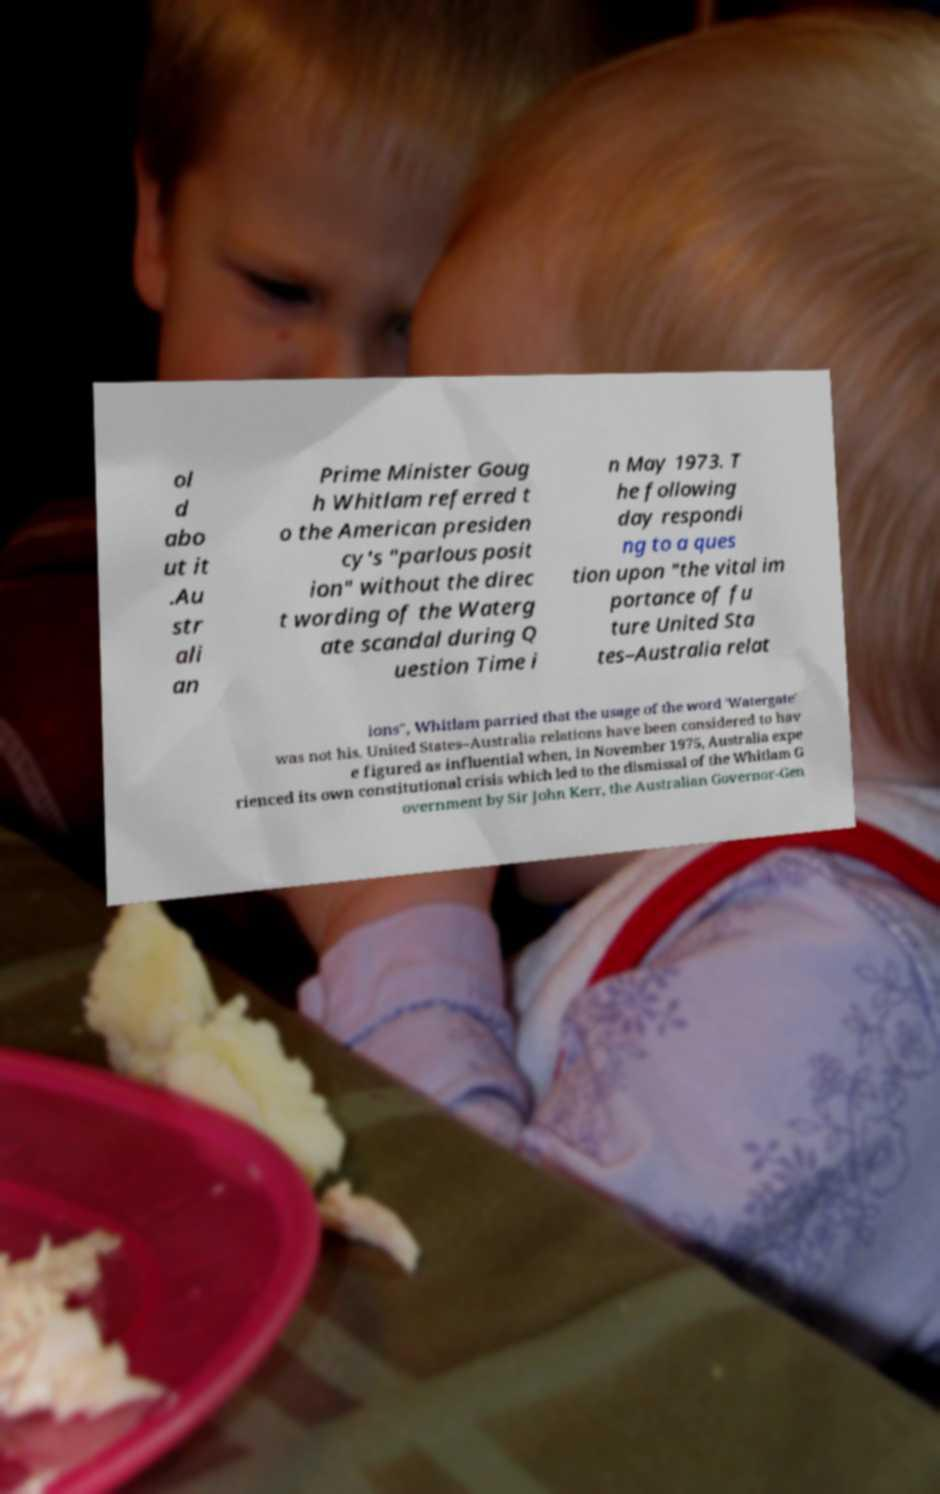Please identify and transcribe the text found in this image. ol d abo ut it .Au str ali an Prime Minister Goug h Whitlam referred t o the American presiden cy's "parlous posit ion" without the direc t wording of the Waterg ate scandal during Q uestion Time i n May 1973. T he following day respondi ng to a ques tion upon "the vital im portance of fu ture United Sta tes–Australia relat ions", Whitlam parried that the usage of the word 'Watergate' was not his. United States–Australia relations have been considered to hav e figured as influential when, in November 1975, Australia expe rienced its own constitutional crisis which led to the dismissal of the Whitlam G overnment by Sir John Kerr, the Australian Governor-Gen 